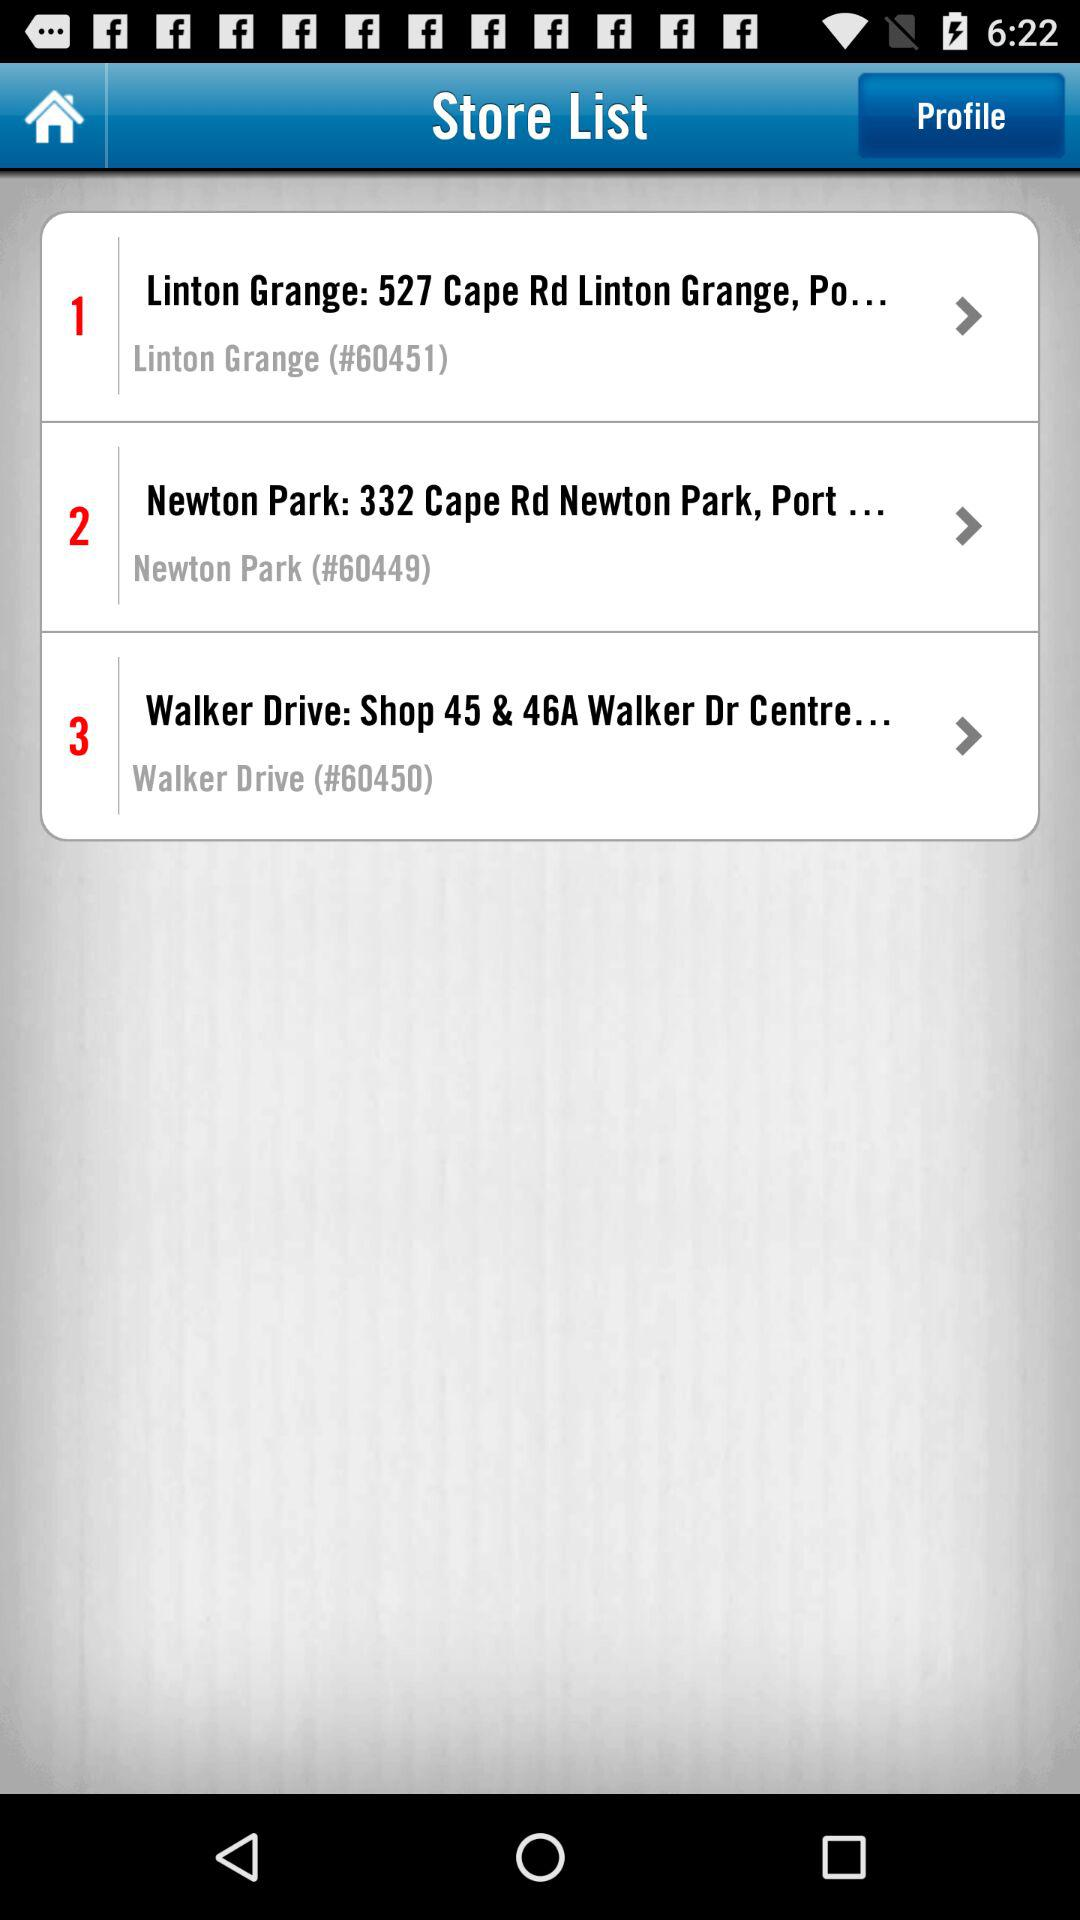What's the code of Linton Grange? The code of Linton Grange is "#60451". 